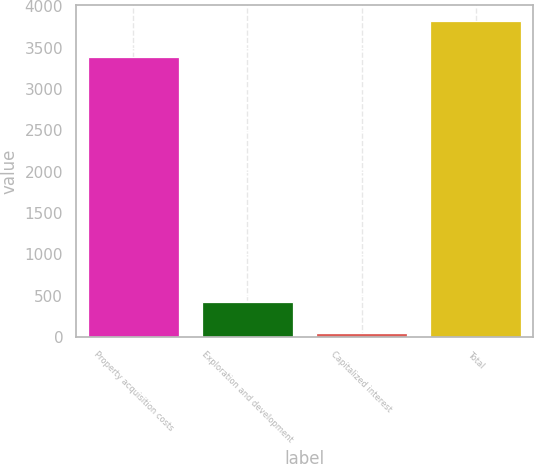Convert chart. <chart><loc_0><loc_0><loc_500><loc_500><bar_chart><fcel>Property acquisition costs<fcel>Exploration and development<fcel>Capitalized interest<fcel>Total<nl><fcel>3391<fcel>425.9<fcel>48<fcel>3827<nl></chart> 